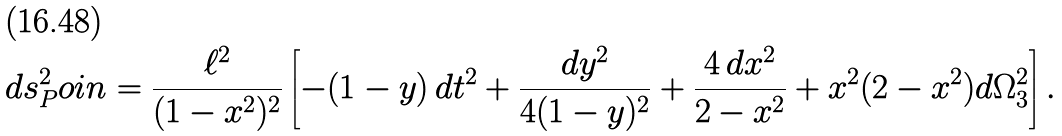Convert formula to latex. <formula><loc_0><loc_0><loc_500><loc_500>d s ^ { 2 } _ { P } o i n = \frac { \ell ^ { 2 } } { ( 1 - x ^ { 2 } ) ^ { 2 } } \left [ - ( 1 - y ) \, d t ^ { 2 } + \frac { d y ^ { 2 } } { 4 ( 1 - y ) ^ { 2 } } + \frac { 4 \, d x ^ { 2 } } { 2 - x ^ { 2 } } + x ^ { 2 } ( 2 - x ^ { 2 } ) d \Omega _ { 3 } ^ { 2 } \right ] .</formula> 